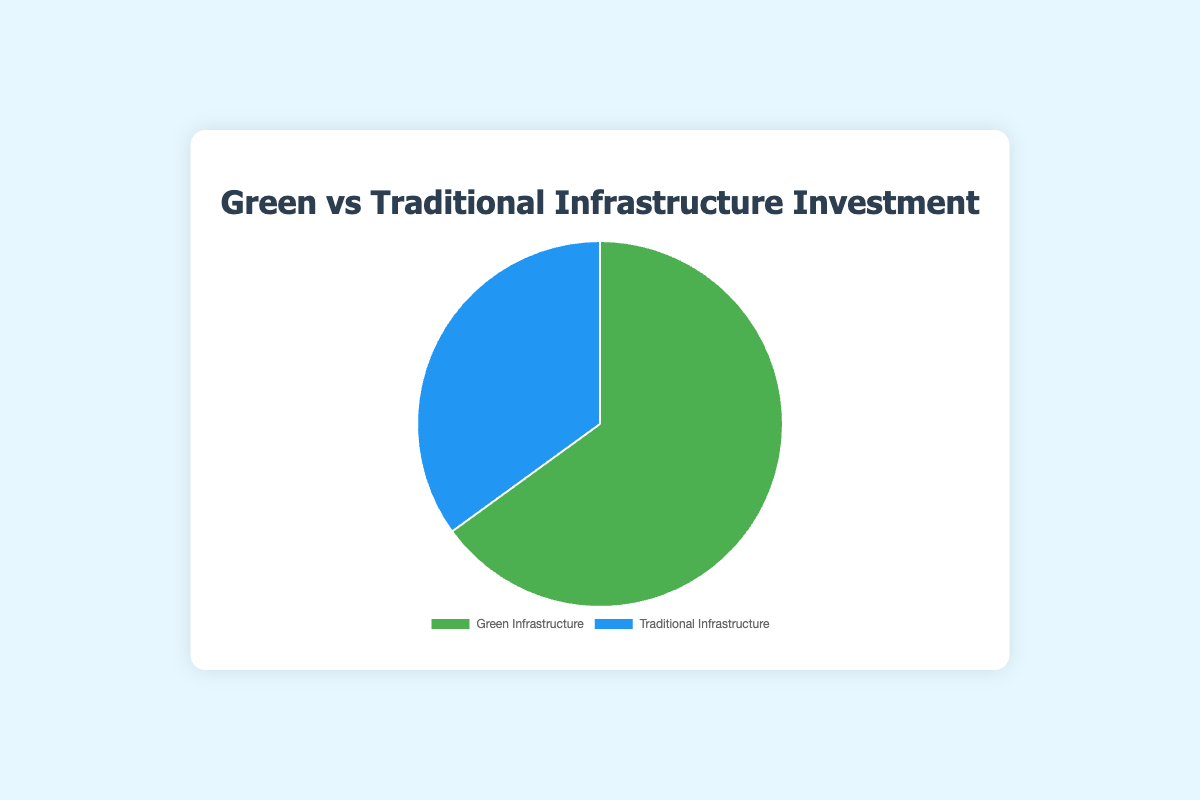Which type of infrastructure has a higher investment percentage? Green Infrastructure has an investment percentage of 65%, which is higher than Traditional Infrastructure with 35%.
Answer: Green Infrastructure What is the difference in investment percentages between Green Infrastructure and Traditional Infrastructure? The investment percentage for Green Infrastructure is 65% and for Traditional Infrastructure is 35%. The difference is 65% - 35% = 30%.
Answer: 30% Which infrastructure type has the smaller investment percentage? Traditional Infrastructure has an investment percentage of 35%, which is smaller than Green Infrastructure's 65%.
Answer: Traditional Infrastructure What's the sum of the investment percentages for both types of infrastructure? Adding the investment percentages for Green Infrastructure (65%) and Traditional Infrastructure (35%) gives 65% + 35% = 100%.
Answer: 100% What percentage of the total investment goes to Traditional Infrastructure? The total investment is 100%, and the percentage allocated to Traditional Infrastructure is 35%.
Answer: 35% If 65% of the investment goes to Green Infrastructure, what percentage does not go to Green Infrastructure? Since 100% of the investment is divided between Green and Traditional Infrastructure, the percentage not going to Green Infrastructure is 100% - 65% = 35%.
Answer: 35% What are the colors used to represent Green and Traditional Infrastructure? Green Infrastructure is represented by green, and Traditional Infrastructure is represented by blue.
Answer: Green for Green Infrastructure and Blue for Traditional Infrastructure If the total investment in stormwater projects is $1 million, how much is invested in Green Infrastructure? 65% of $1 million is invested in Green Infrastructure. 0.65 * $1 million = $650,000.
Answer: $650,000 What percentage of the investment is allocated to non-Traditional Infrastructure? Non-Traditional Infrastructure refers to Green Infrastructure, which receives 65% of the investment.
Answer: 65% Which section of the pie chart is larger by visual area? The section representing Green Infrastructure is larger by visual area compared to the section representing Traditional Infrastructure.
Answer: Green Infrastructure 